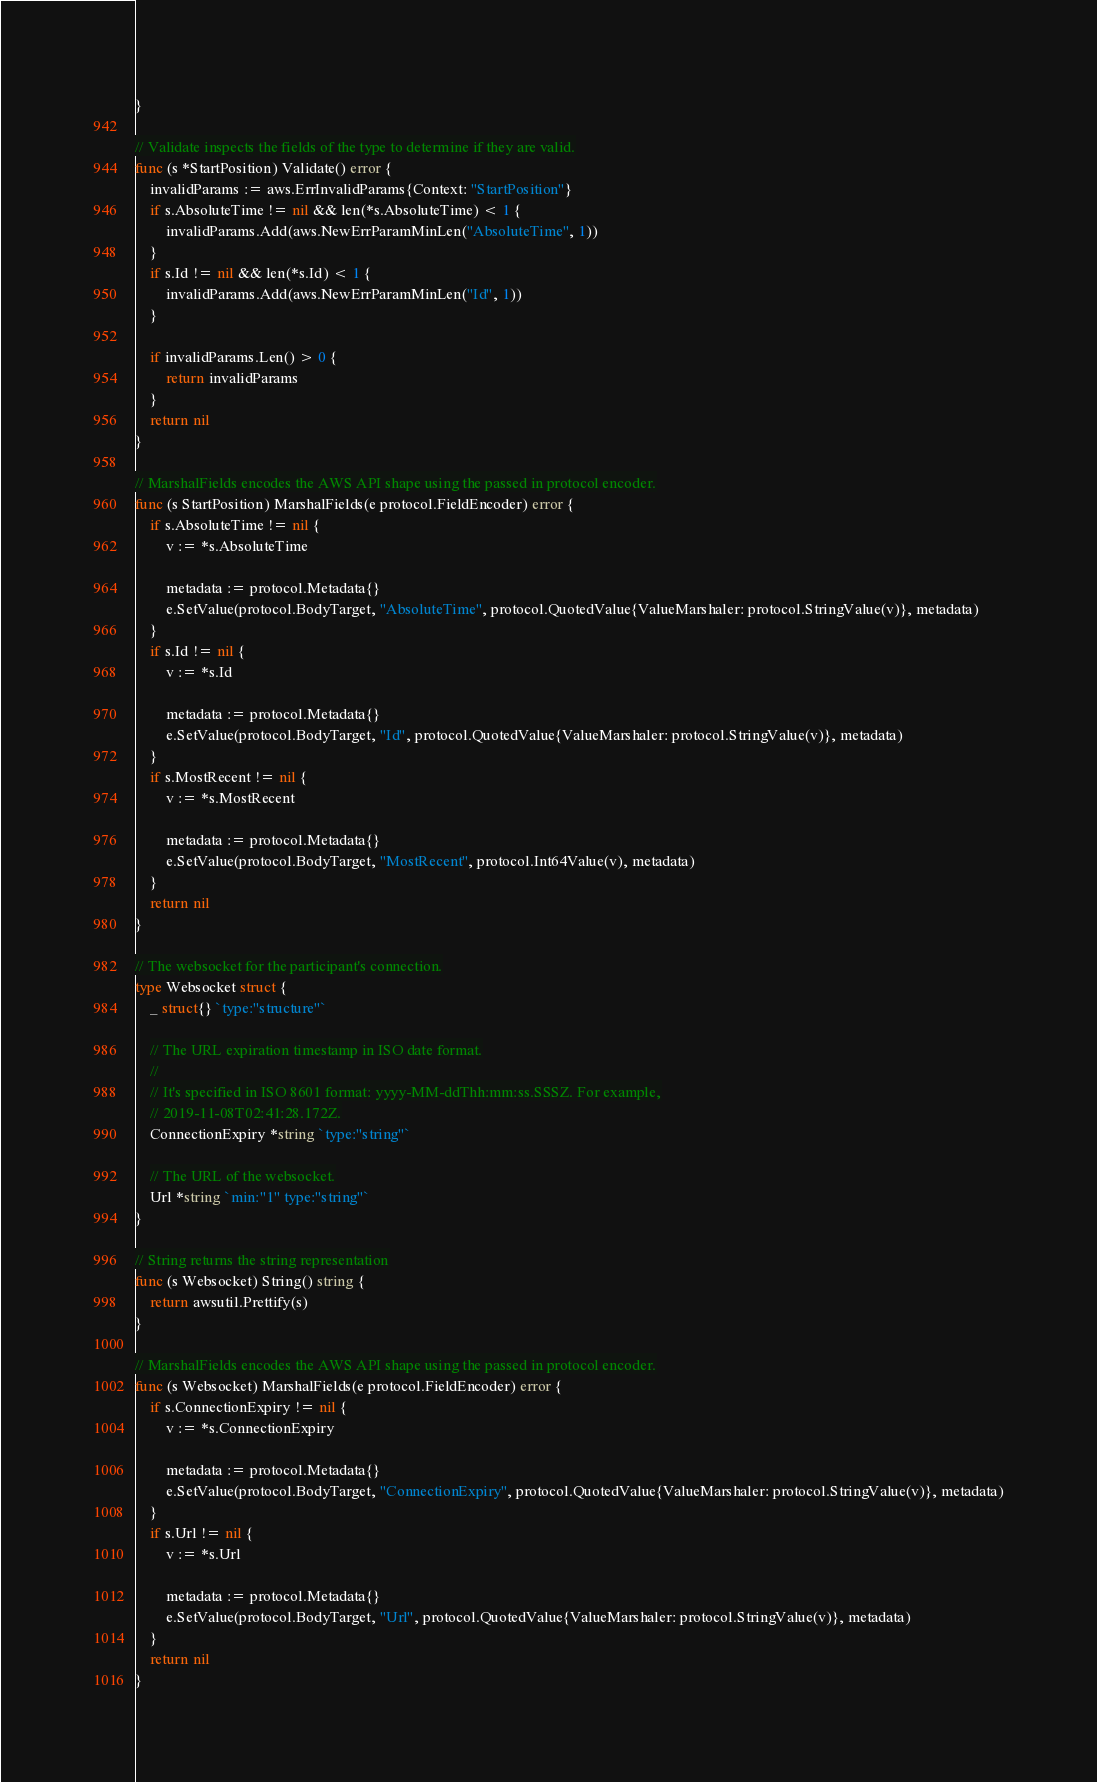Convert code to text. <code><loc_0><loc_0><loc_500><loc_500><_Go_>}

// Validate inspects the fields of the type to determine if they are valid.
func (s *StartPosition) Validate() error {
	invalidParams := aws.ErrInvalidParams{Context: "StartPosition"}
	if s.AbsoluteTime != nil && len(*s.AbsoluteTime) < 1 {
		invalidParams.Add(aws.NewErrParamMinLen("AbsoluteTime", 1))
	}
	if s.Id != nil && len(*s.Id) < 1 {
		invalidParams.Add(aws.NewErrParamMinLen("Id", 1))
	}

	if invalidParams.Len() > 0 {
		return invalidParams
	}
	return nil
}

// MarshalFields encodes the AWS API shape using the passed in protocol encoder.
func (s StartPosition) MarshalFields(e protocol.FieldEncoder) error {
	if s.AbsoluteTime != nil {
		v := *s.AbsoluteTime

		metadata := protocol.Metadata{}
		e.SetValue(protocol.BodyTarget, "AbsoluteTime", protocol.QuotedValue{ValueMarshaler: protocol.StringValue(v)}, metadata)
	}
	if s.Id != nil {
		v := *s.Id

		metadata := protocol.Metadata{}
		e.SetValue(protocol.BodyTarget, "Id", protocol.QuotedValue{ValueMarshaler: protocol.StringValue(v)}, metadata)
	}
	if s.MostRecent != nil {
		v := *s.MostRecent

		metadata := protocol.Metadata{}
		e.SetValue(protocol.BodyTarget, "MostRecent", protocol.Int64Value(v), metadata)
	}
	return nil
}

// The websocket for the participant's connection.
type Websocket struct {
	_ struct{} `type:"structure"`

	// The URL expiration timestamp in ISO date format.
	//
	// It's specified in ISO 8601 format: yyyy-MM-ddThh:mm:ss.SSSZ. For example,
	// 2019-11-08T02:41:28.172Z.
	ConnectionExpiry *string `type:"string"`

	// The URL of the websocket.
	Url *string `min:"1" type:"string"`
}

// String returns the string representation
func (s Websocket) String() string {
	return awsutil.Prettify(s)
}

// MarshalFields encodes the AWS API shape using the passed in protocol encoder.
func (s Websocket) MarshalFields(e protocol.FieldEncoder) error {
	if s.ConnectionExpiry != nil {
		v := *s.ConnectionExpiry

		metadata := protocol.Metadata{}
		e.SetValue(protocol.BodyTarget, "ConnectionExpiry", protocol.QuotedValue{ValueMarshaler: protocol.StringValue(v)}, metadata)
	}
	if s.Url != nil {
		v := *s.Url

		metadata := protocol.Metadata{}
		e.SetValue(protocol.BodyTarget, "Url", protocol.QuotedValue{ValueMarshaler: protocol.StringValue(v)}, metadata)
	}
	return nil
}
</code> 